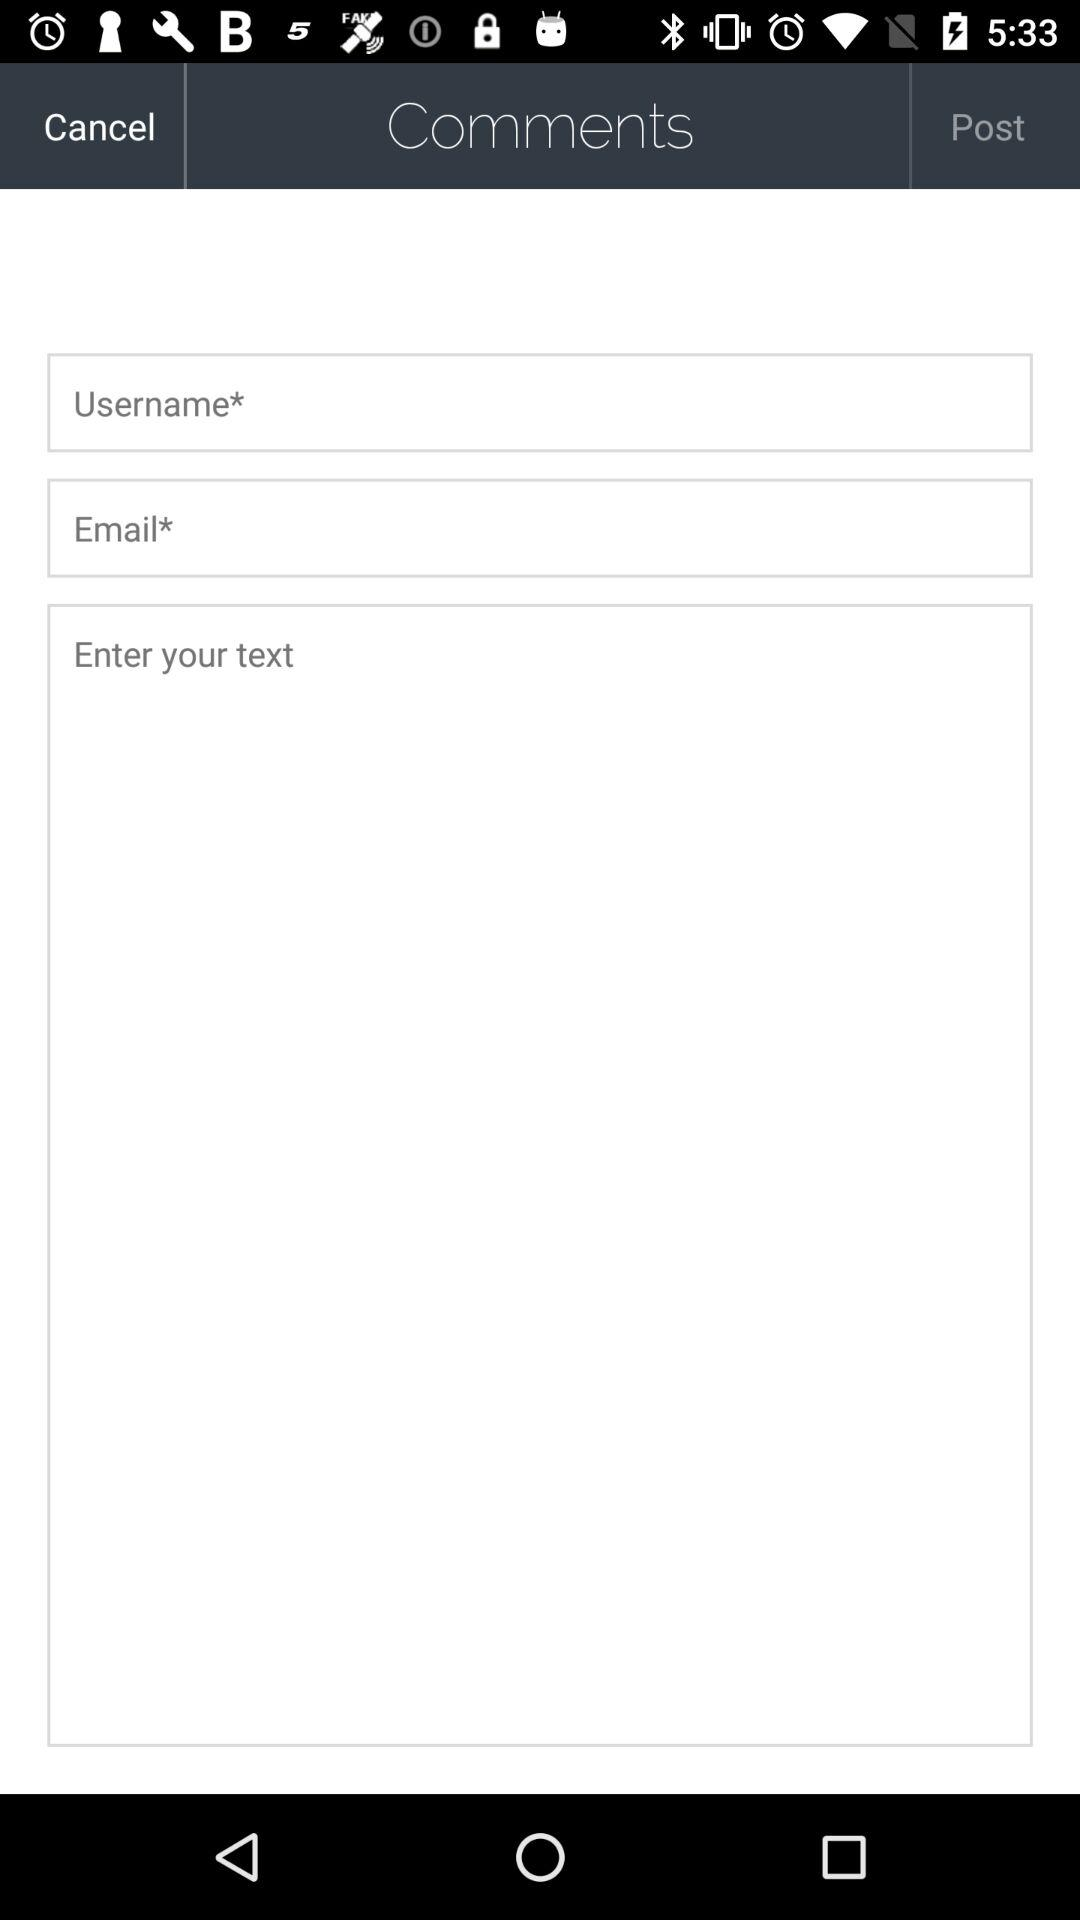How many text inputs are on the screen?
Answer the question using a single word or phrase. 3 